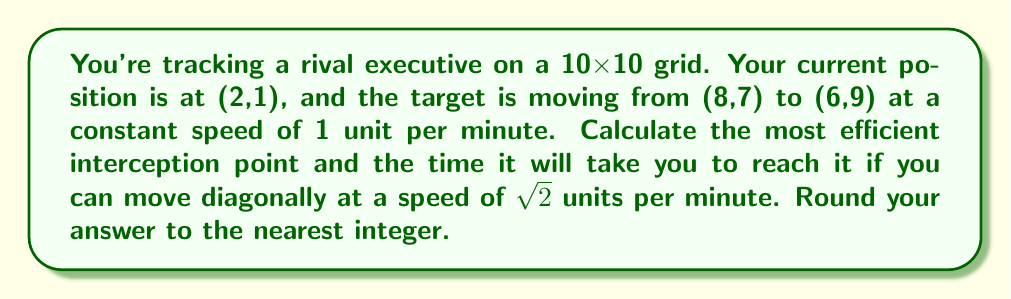Give your solution to this math problem. 1) First, let's parametrize the target's path:
   $$x = 8 - 2t$$
   $$y = 7 + t$$
   where $t$ is time in minutes.

2) Your position can be represented as:
   $$x' = 2 + \sqrt{2}t\cos\theta$$
   $$y' = 1 + \sqrt{2}t\sin\theta$$
   where $\theta$ is the angle of your movement.

3) For interception, these must be equal:
   $$8 - 2t = 2 + \sqrt{2}t\cos\theta$$
   $$7 + t = 1 + \sqrt{2}t\sin\theta$$

4) Solving these equations simultaneously:
   $$6 - 2t = \sqrt{2}t\cos\theta$$
   $$6 - t = \sqrt{2}t\sin\theta$$

5) Squaring and adding these equations:
   $$(6-2t)^2 + (6-t)^2 = 2t^2$$

6) Simplifying:
   $$36 - 24t + 4t^2 + 36 - 12t + t^2 = 2t^2$$
   $$72 - 36t + 5t^2 = 2t^2$$
   $$72 - 36t + 3t^2 = 0$$

7) Solving this quadratic equation:
   $$t = \frac{36 \pm \sqrt{1296 - 864}}{6} = \frac{36 \pm \sqrt{432}}{6} = 6 \pm 2\sqrt{3}$$

8) We take the smaller solution:
   $$t = 6 - 2\sqrt{3} \approx 2.54 \text{ minutes}$$

9) The interception point is:
   $$x = 8 - 2(2.54) \approx 2.92$$
   $$y = 7 + 2.54 \approx 9.54$$

10) Rounding to the nearest integer:
    Interception point: (3, 10)
    Time: 3 minutes
Answer: (3, 10), 3 minutes 